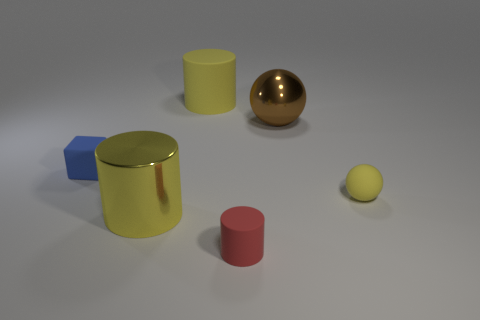Add 1 small objects. How many objects exist? 7 Subtract all cubes. How many objects are left? 5 Subtract 0 gray cubes. How many objects are left? 6 Subtract all yellow rubber cylinders. Subtract all large yellow cylinders. How many objects are left? 3 Add 4 big yellow matte objects. How many big yellow matte objects are left? 5 Add 3 small cylinders. How many small cylinders exist? 4 